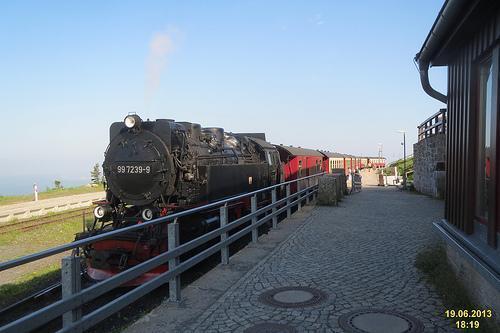How many circles are on the ground?
Give a very brief answer. 2. How many trees are in the photo?
Give a very brief answer. 2. 